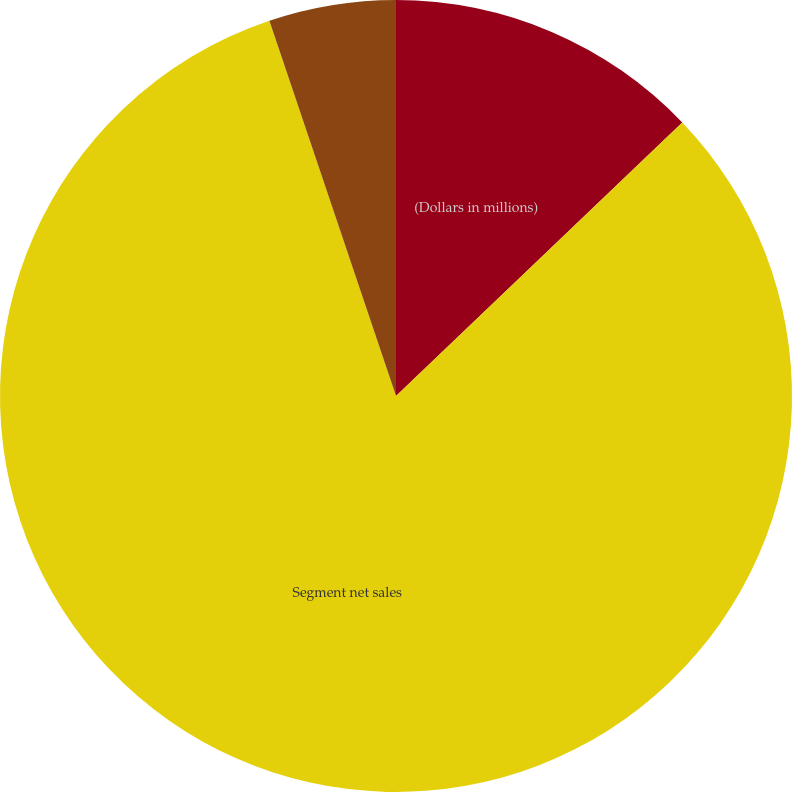Convert chart to OTSL. <chart><loc_0><loc_0><loc_500><loc_500><pie_chart><fcel>(Dollars in millions)<fcel>Segment net sales<fcel>Operating earnings (loss)<nl><fcel>12.86%<fcel>81.96%<fcel>5.18%<nl></chart> 